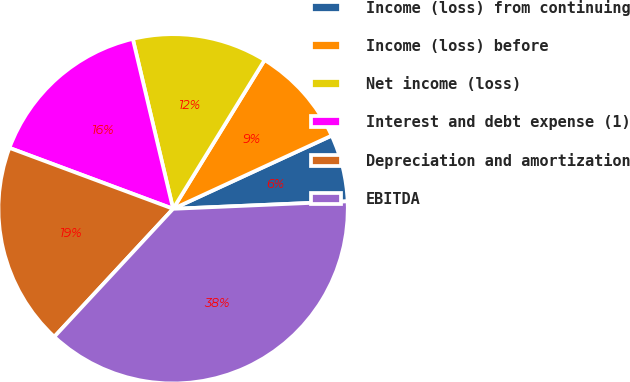Convert chart. <chart><loc_0><loc_0><loc_500><loc_500><pie_chart><fcel>Income (loss) from continuing<fcel>Income (loss) before<fcel>Net income (loss)<fcel>Interest and debt expense (1)<fcel>Depreciation and amortization<fcel>EBITDA<nl><fcel>6.2%<fcel>9.34%<fcel>12.48%<fcel>15.62%<fcel>18.76%<fcel>37.59%<nl></chart> 